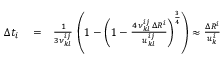<formula> <loc_0><loc_0><loc_500><loc_500>\begin{array} { r l r } { \Delta t _ { i } } & = } & { \frac { 1 } { 3 \nu _ { k l } ^ { i j } } \, \left ( 1 - \left ( 1 - \frac { 4 \, \nu _ { k l } ^ { i j } \, \Delta R ^ { i } } { u _ { k l } ^ { i j } } \right ) ^ { \frac { 3 } { 4 } } \right ) \approx \frac { \Delta R ^ { i } } { u _ { k } ^ { i } } } \end{array}</formula> 